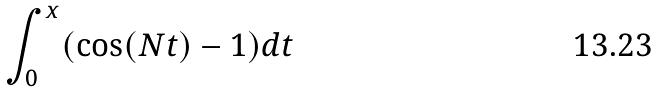<formula> <loc_0><loc_0><loc_500><loc_500>\int _ { 0 } ^ { x } ( \cos ( N t ) - 1 ) d t</formula> 